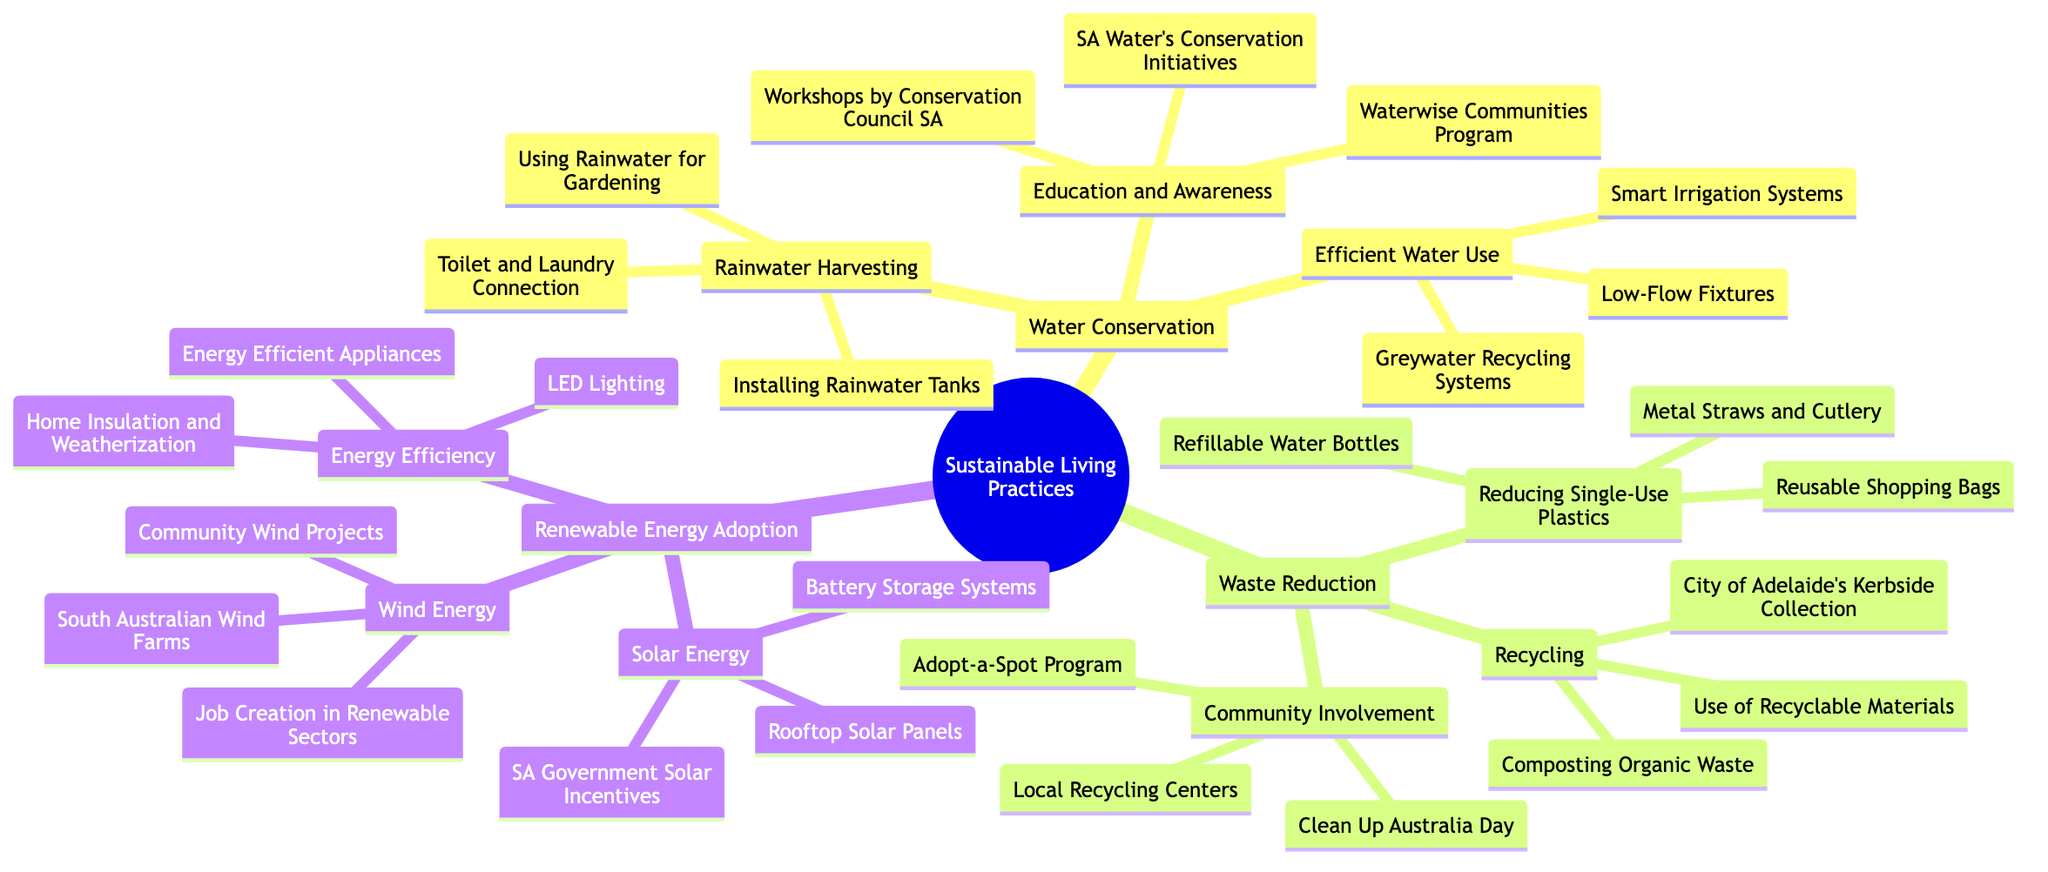What are the main categories of sustainable living practices in the diagram? The diagram outlines three main categories under "Sustainable Living Practices": Water Conservation, Waste Reduction, and Renewable Energy Adoption.
Answer: Water Conservation, Waste Reduction, Renewable Energy Adoption How many methods are listed under "Waste Reduction"? Under "Waste Reduction," there are three methods displayed: Recycling, Reducing Single-Use Plastics, and Community Involvement.
Answer: 3 What is one way to conserve water listed in the diagram? The diagram provides various methods under Water Conservation. One example is "Installing Rainwater Tanks," which is an actionable step to practice water conservation.
Answer: Installing Rainwater Tanks Which renewable energy source is associated with battery storage systems? The diagram directly connects "Battery Storage Systems" under "Solar Energy," indicating that it trains on the solar renewable energy source.
Answer: Solar Energy What community involvement activity is mentioned for waste reduction? The diagram includes "Clean Up Australia Day" as a community-focused initiative aimed at waste reduction under the "Community Involvement" category of Waste Reduction.
Answer: Clean Up Australia Day How does "Energy Efficiency" contribute to renewable energy adoption? "Energy Efficiency" focuses on measures such as "Energy Efficient Appliances," "LED Lighting," and "Home Insulation and Weatherization" which help reduce overall energy demand, thus supporting the adoption of renewable energy sources by lowering consumption rates.
Answer: Energy Efficiency Which program focuses on education and awareness about water conservation? The diagram lists "Waterwise Communities Program" as part of the initiatives aimed at education and awareness under the "Education and Awareness" category related to Water Conservation.
Answer: Waterwise Communities Program What is one method listed under "Recycling"? Under the "Recycling" method in Waste Reduction, one specific example given is "Composting Organic Waste." This process is integral to effective recycling practices.
Answer: Composting Organic Waste 